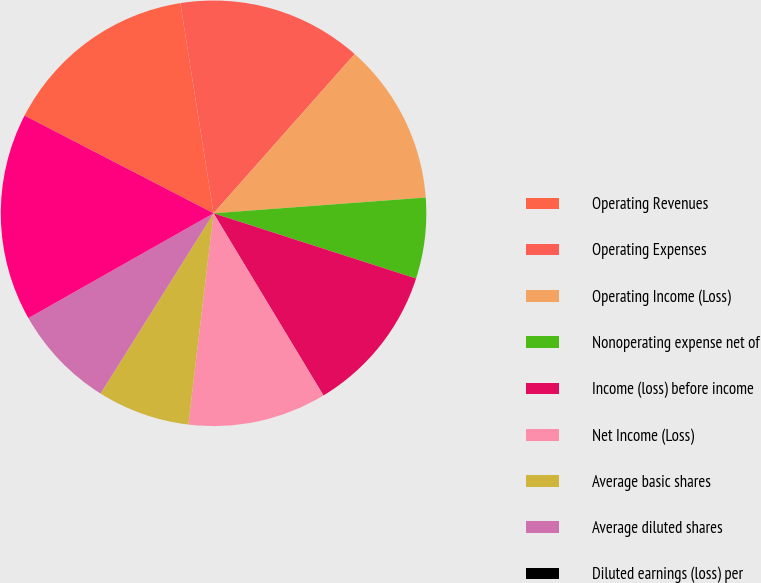Convert chart to OTSL. <chart><loc_0><loc_0><loc_500><loc_500><pie_chart><fcel>Operating Revenues<fcel>Operating Expenses<fcel>Operating Income (Loss)<fcel>Nonoperating expense net of<fcel>Income (loss) before income<fcel>Net Income (Loss)<fcel>Average basic shares<fcel>Average diluted shares<fcel>Diluted earnings (loss) per<fcel>Total assets Long-term debt<nl><fcel>14.91%<fcel>14.03%<fcel>12.28%<fcel>6.14%<fcel>11.4%<fcel>10.53%<fcel>7.02%<fcel>7.89%<fcel>0.0%<fcel>15.79%<nl></chart> 